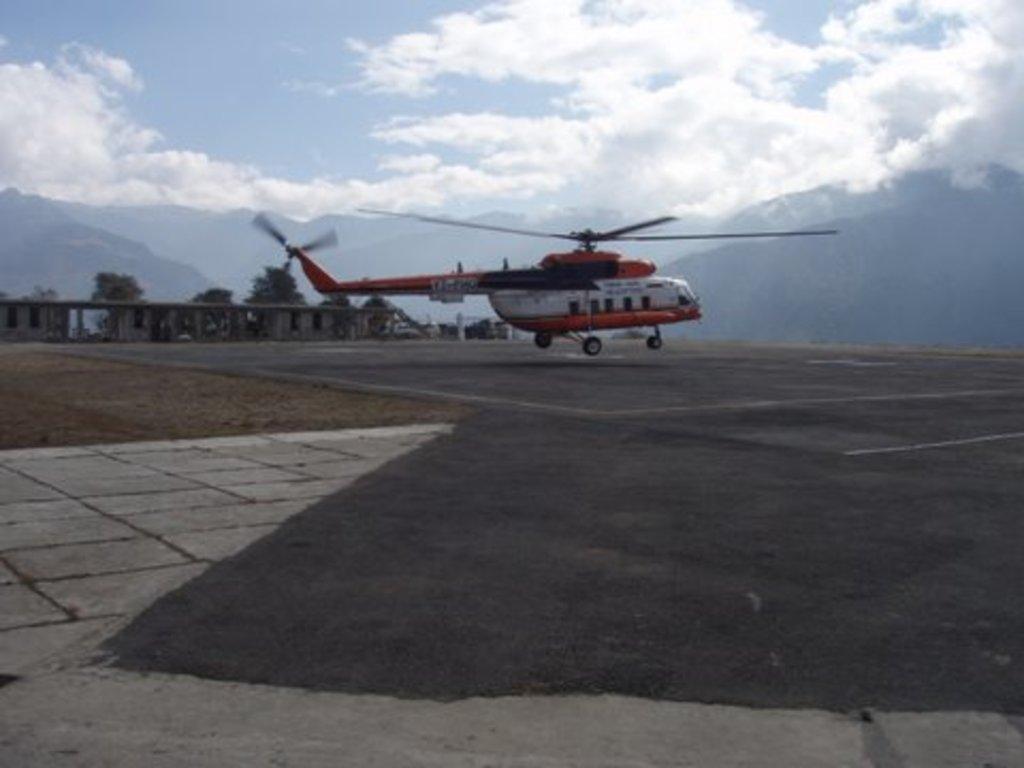Please provide a concise description of this image. In this image we can see a helicopter. At the bottom of the image there is road. In the background of the image there are mountains, trees, sky and clouds. 